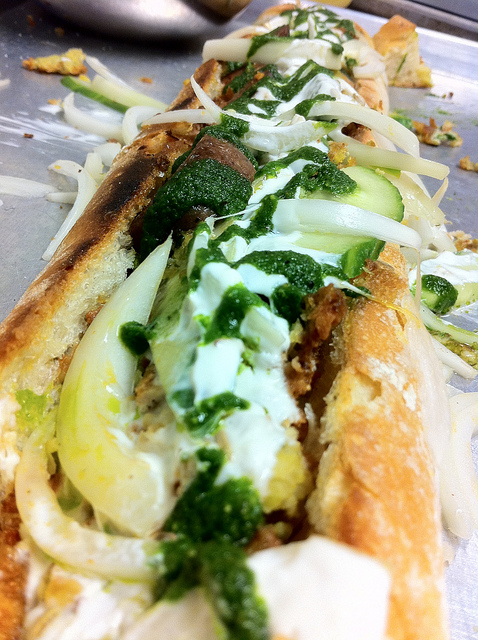<image>Did Subway make this? I am not sure if Subway made this. Is this a sandwich for one? It is not clear if this is a sandwich for one. The answer can be both yes or no. Did Subway make this? I am not sure if Subway made this. It can be either yes or no. Is this a sandwich for one? I don't know if this is a sandwich for one. It can be either yes or no. 